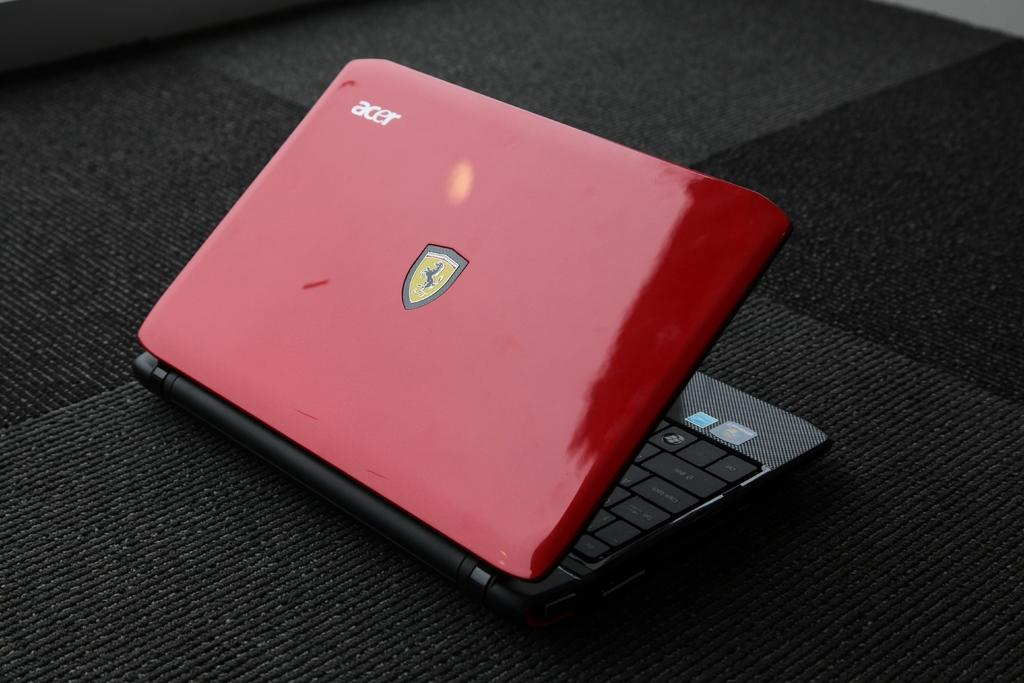What electronic device is present in the image? There is a laptop in the picture. What is the color of the laptop? The laptop is red in color. What symbol can be seen on the laptop? The laptop has a Ferrari symbol on it. What brand name is visible on the laptop? The laptop has the name "ACER" on it. What is the laptop placed on in the image? The laptop is placed on a black color mat. How many pigs are visible in the image? There are no pigs present in the image. What type of stem can be seen growing from the laptop? There is no stem visible in the image; it is a picture of a laptop. 